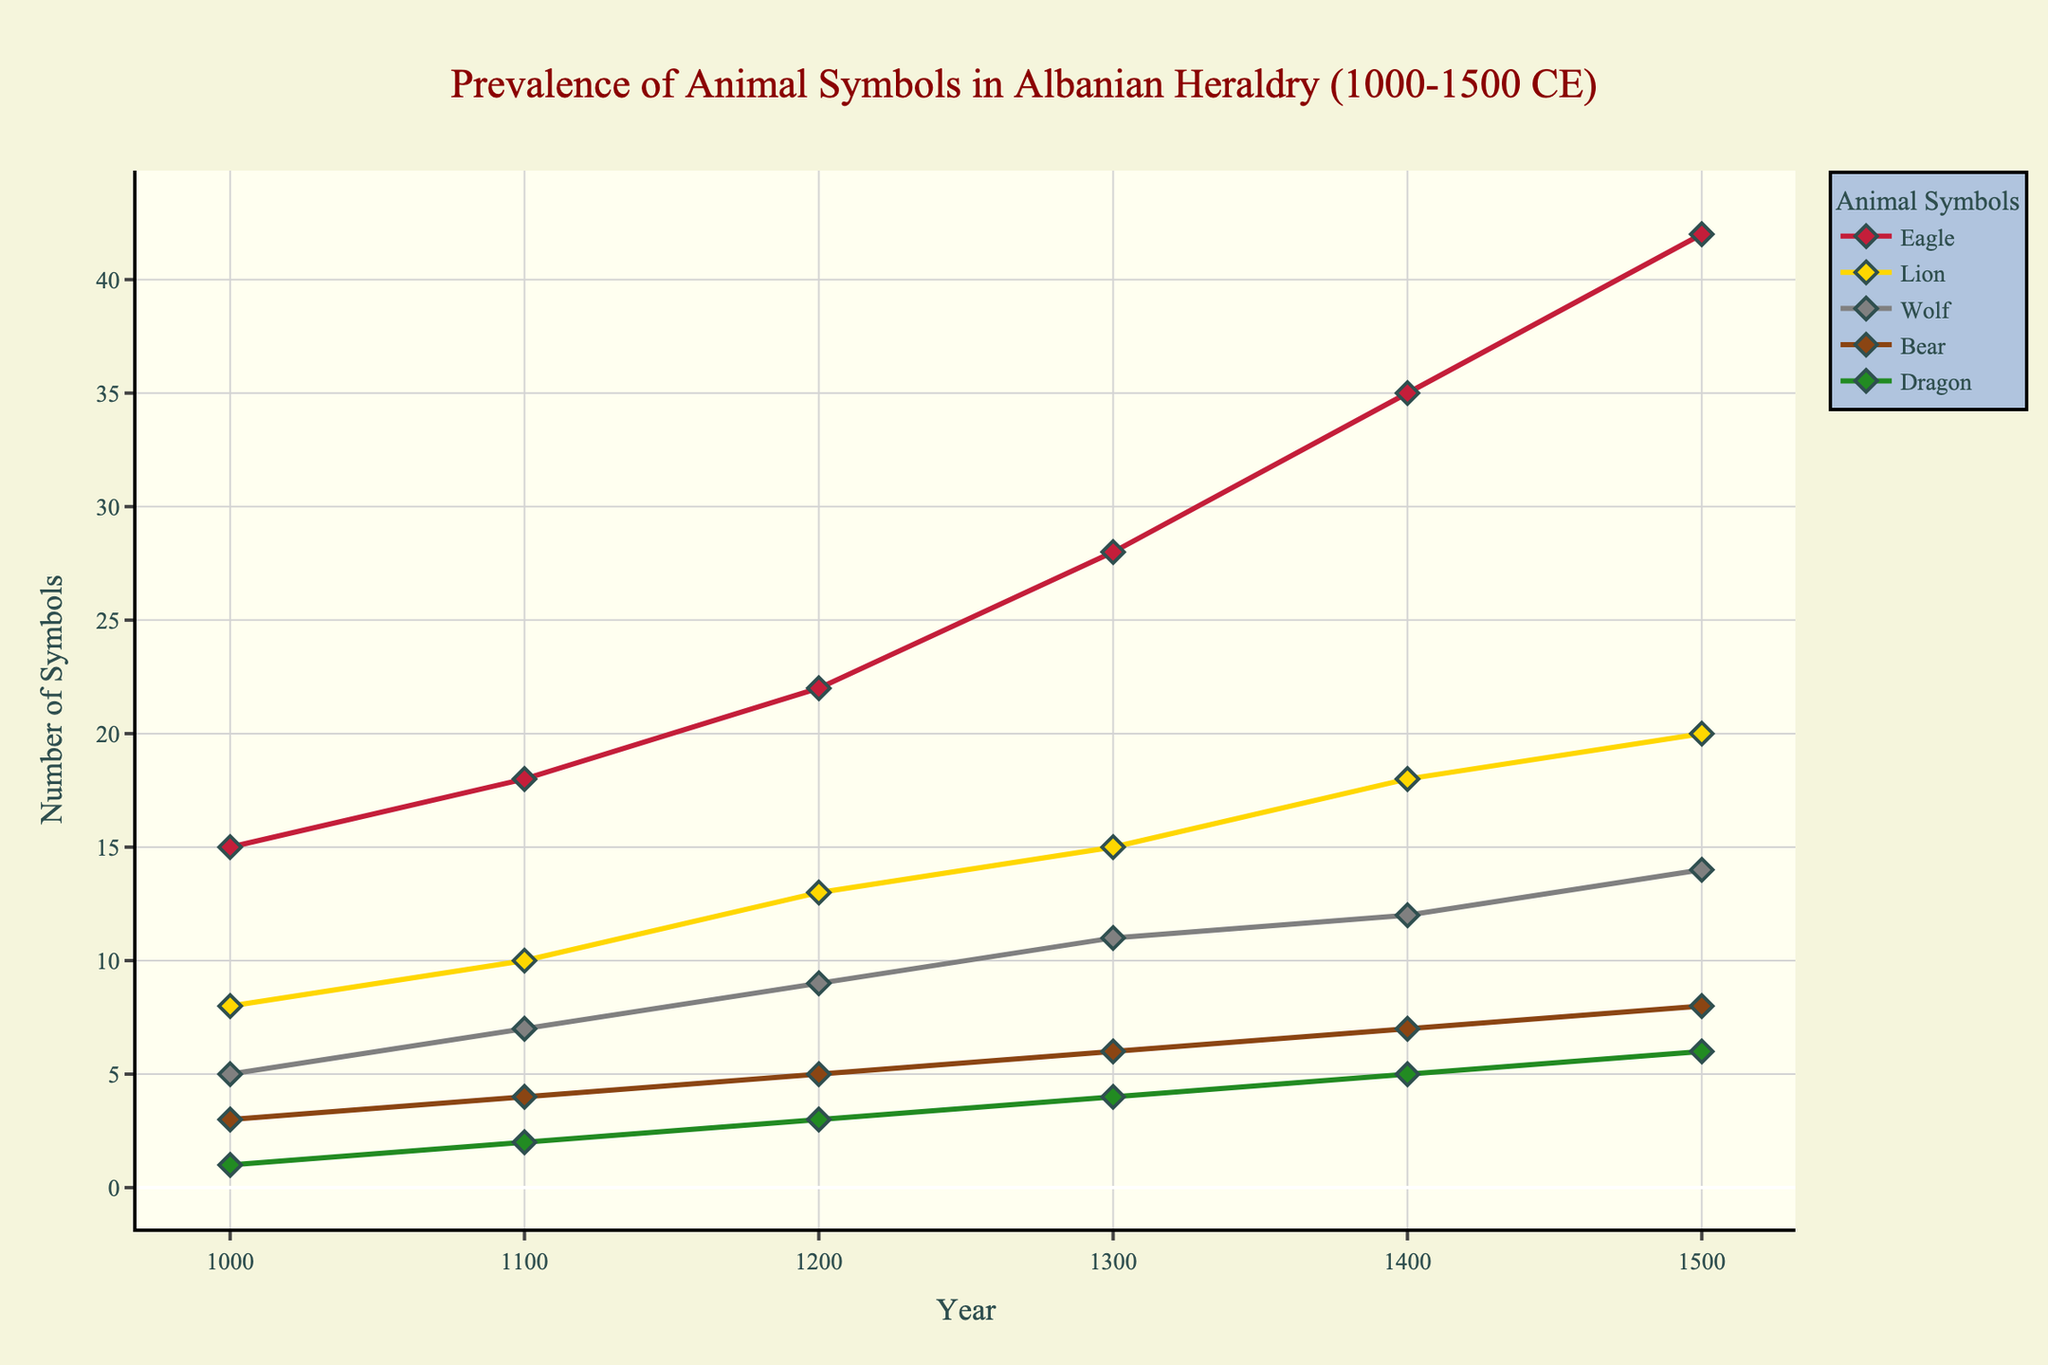What is the total number of Eagle symbols in 1400 and 1500? To find the total number of Eagle symbols in 1400 and 1500, you sum the values for those years. In 1400, there are 35 Eagle symbols, and in 1500, there are 42. Summing these values, we get 35 + 42 = 77.
Answer: 77 Which animal symbol has the highest prevalence in 1300? To determine the animal symbol with the highest prevalence in 1300, we compare all the values for the year 1300. The values are: Eagle (28), Lion (15), Wolf (11), Bear (6), and Dragon (4). The Eagle has the highest value of 28.
Answer: Eagle What is the difference in the number of Lion symbols between the years 1000 and 1500? To find the difference, subtract the number of Lion symbols in 1000 from the number of Lion symbols in 1500. In 1000, there are 8 Lion symbols, and in 1500, there are 20. The difference is 20 - 8 = 12.
Answer: 12 Compare the growth of the Wolf and Bear symbols between 1000 and 1500. Which grew more? To compare the growth, we calculate the increase for both symbols from 1000 to 1500. For Wolves: 14 (1500) - 5 (1000) = 9. For Bears: 8 (1500) - 3 (1000) = 5. Thus, the Wolf symbol grew more by 4.
Answer: Wolf What is the average number of Dragon symbols throughout the six given years? To find the average, sum the number of Dragon symbols in the years 1000, 1100, 1200, 1300, 1400, and 1500, and then divide by 6. The sum is 1 + 2 + 3 + 4 + 5 + 6 = 21. The average is 21 / 6 = 3.5.
Answer: 3.5 What are the growth rates of the Eagle and Lion symbols from 1000 to 1500? To calculate the growth rate, we use the formula [(final value - initial value) / initial value] * 100. For Eagles: [(42 - 15) / 15] * 100 = 180%. For Lions: [(20 - 8) / 8] * 100 = 150%.
Answer: Eagle: 180%, Lion: 150% Between which two adjacent centuries did the Bear symbol exhibit the highest increase? To find this, calculate the increase between each adjacent century and identify the highest one. 
- From 1000 to 1100: 4 - 3 = 1 
- From 1100 to 1200: 5 - 4 = 1 
- From 1200 to 1300: 6 - 5 = 1 
- From 1300 to 1400: 7 - 6 = 1 
- From 1400 to 1500: 8 - 7 = 1 
The increase is the same across all centuries.
Answer: All increases are the same: 1 What is the combined total of Eagle and Dragon symbols in the year 1300? To find the combined total, sum the number of Eagle and Dragon symbols in 1300. Eagle: 28, Dragon: 4. The total is 28 + 4 = 32.
Answer: 32 